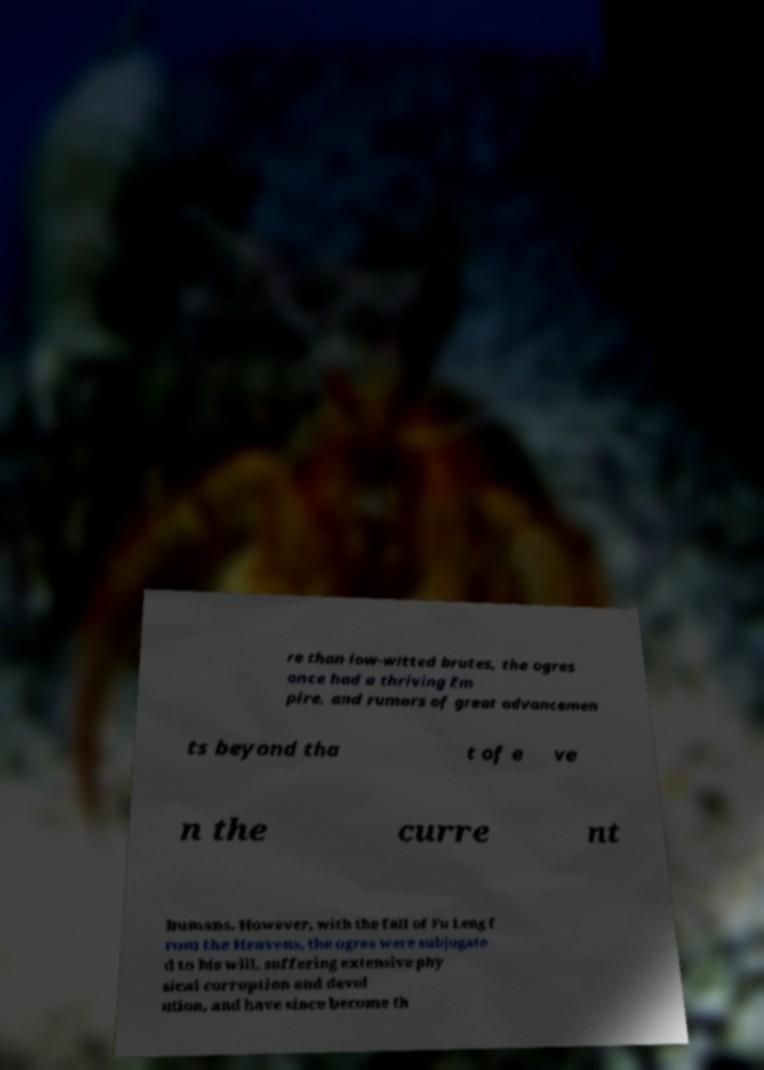There's text embedded in this image that I need extracted. Can you transcribe it verbatim? re than low-witted brutes, the ogres once had a thriving Em pire, and rumors of great advancemen ts beyond tha t of e ve n the curre nt humans. However, with the fall of Fu Leng f rom the Heavens, the ogres were subjugate d to his will, suffering extensive phy sical corruption and devol ution, and have since become th 